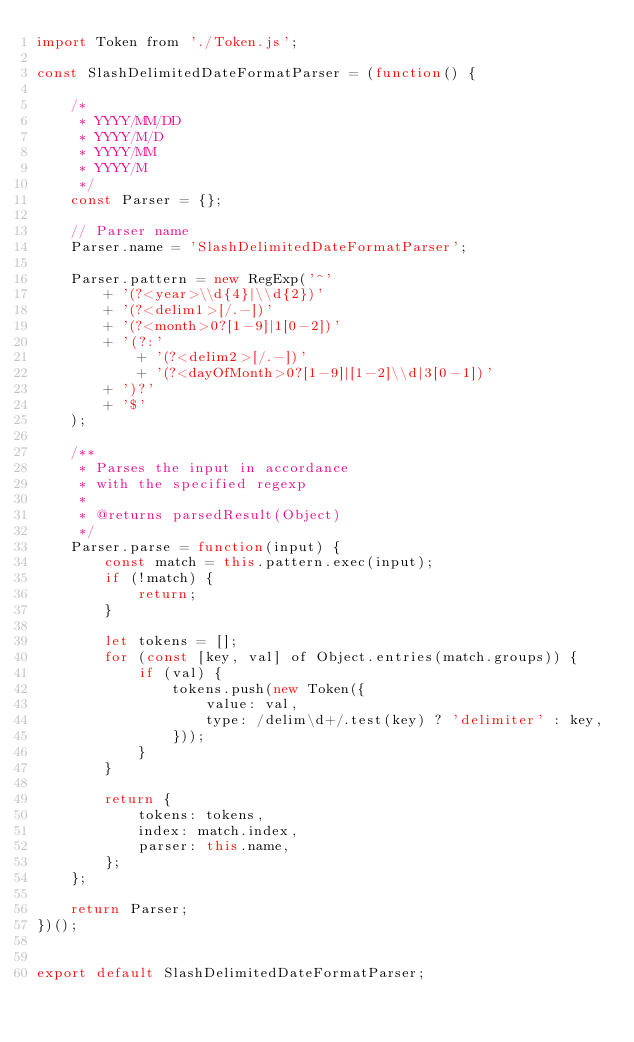Convert code to text. <code><loc_0><loc_0><loc_500><loc_500><_JavaScript_>import Token from './Token.js';

const SlashDelimitedDateFormatParser = (function() {

	/*
	 * YYYY/MM/DD
	 * YYYY/M/D
	 * YYYY/MM
	 * YYYY/M
	 */
	const Parser = {};

	// Parser name
	Parser.name = 'SlashDelimitedDateFormatParser';

	Parser.pattern = new RegExp('^'
		+ '(?<year>\\d{4}|\\d{2})'
		+ '(?<delim1>[/.-])'
		+ '(?<month>0?[1-9]|1[0-2])'
		+ '(?:'
			+ '(?<delim2>[/.-])'
			+ '(?<dayOfMonth>0?[1-9]|[1-2]\\d|3[0-1])'
		+ ')?'
		+ '$'
	);

	/**
	 * Parses the input in accordance
	 * with the specified regexp
	 *
	 * @returns parsedResult(Object)
	 */
	Parser.parse = function(input) {
		const match = this.pattern.exec(input);
		if (!match) {
			return;
		}

		let tokens = [];
		for (const [key, val] of Object.entries(match.groups)) {
			if (val) {
				tokens.push(new Token({
					value: val,
					type: /delim\d+/.test(key) ? 'delimiter' : key,
				}));
			}
		}

		return {
			tokens: tokens,
			index: match.index,
			parser: this.name,
		};
	};

	return Parser;
})();


export default SlashDelimitedDateFormatParser;
</code> 